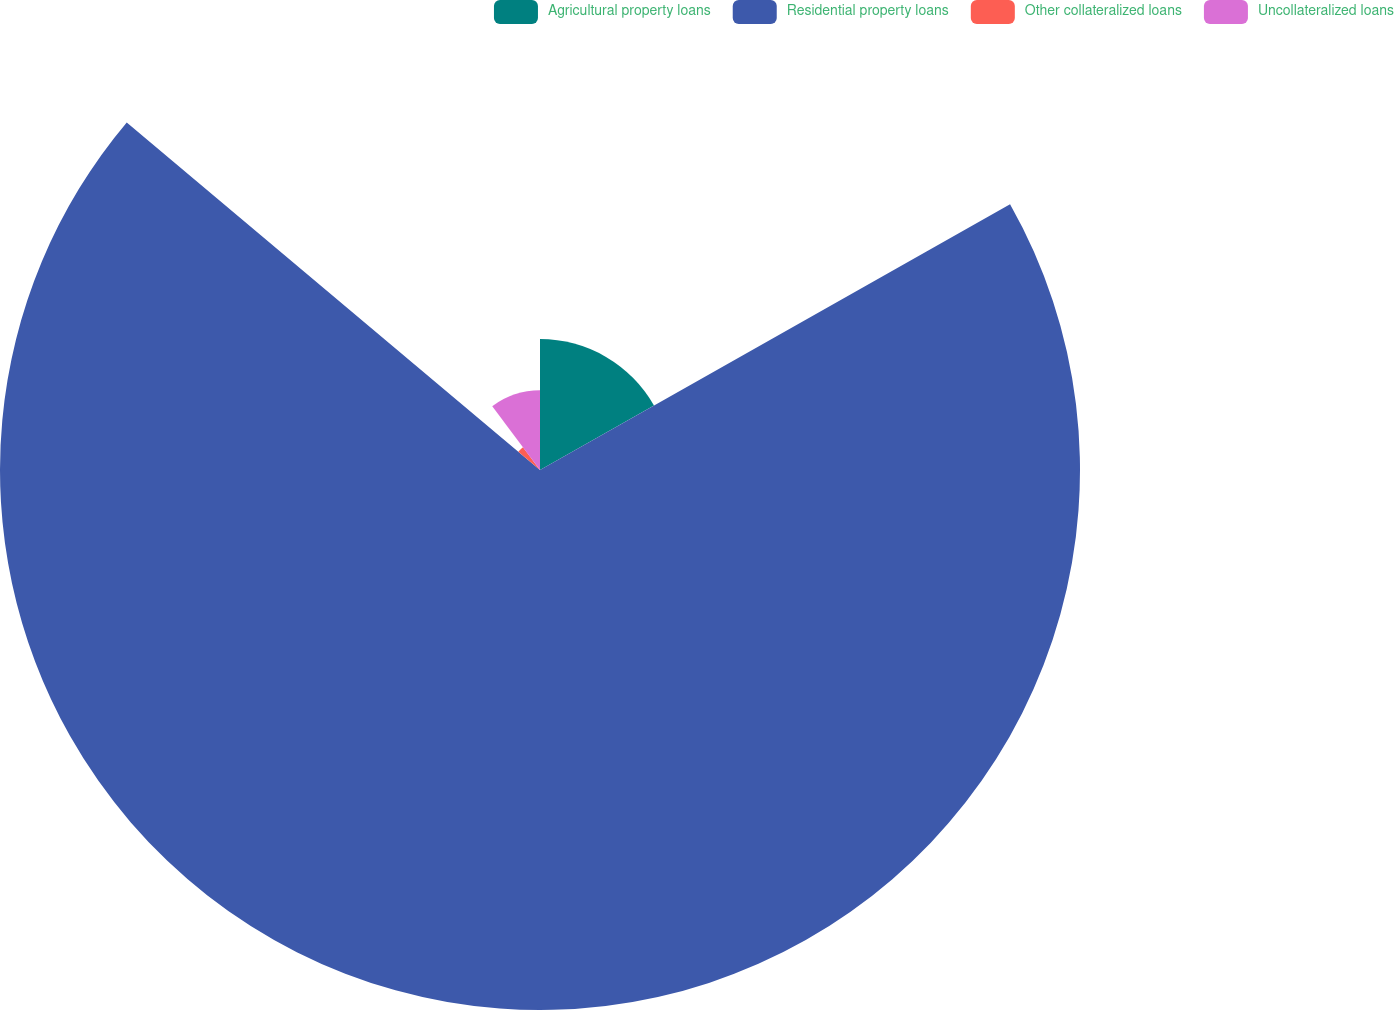Convert chart to OTSL. <chart><loc_0><loc_0><loc_500><loc_500><pie_chart><fcel>Agricultural property loans<fcel>Residential property loans<fcel>Other collateralized loans<fcel>Uncollateralized loans<nl><fcel>16.81%<fcel>69.32%<fcel>3.64%<fcel>10.23%<nl></chart> 